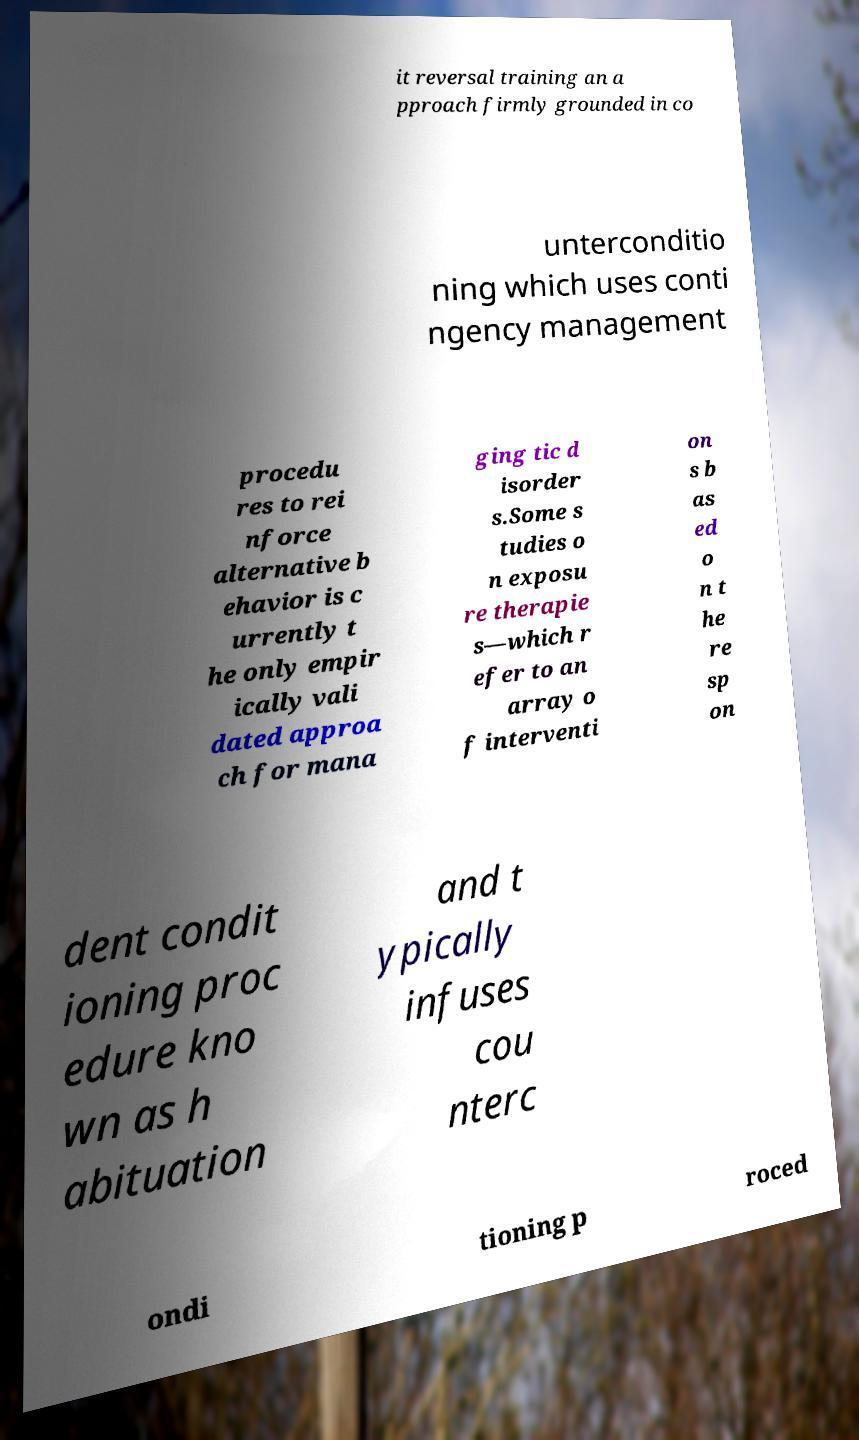Please read and relay the text visible in this image. What does it say? it reversal training an a pproach firmly grounded in co unterconditio ning which uses conti ngency management procedu res to rei nforce alternative b ehavior is c urrently t he only empir ically vali dated approa ch for mana ging tic d isorder s.Some s tudies o n exposu re therapie s—which r efer to an array o f interventi on s b as ed o n t he re sp on dent condit ioning proc edure kno wn as h abituation and t ypically infuses cou nterc ondi tioning p roced 